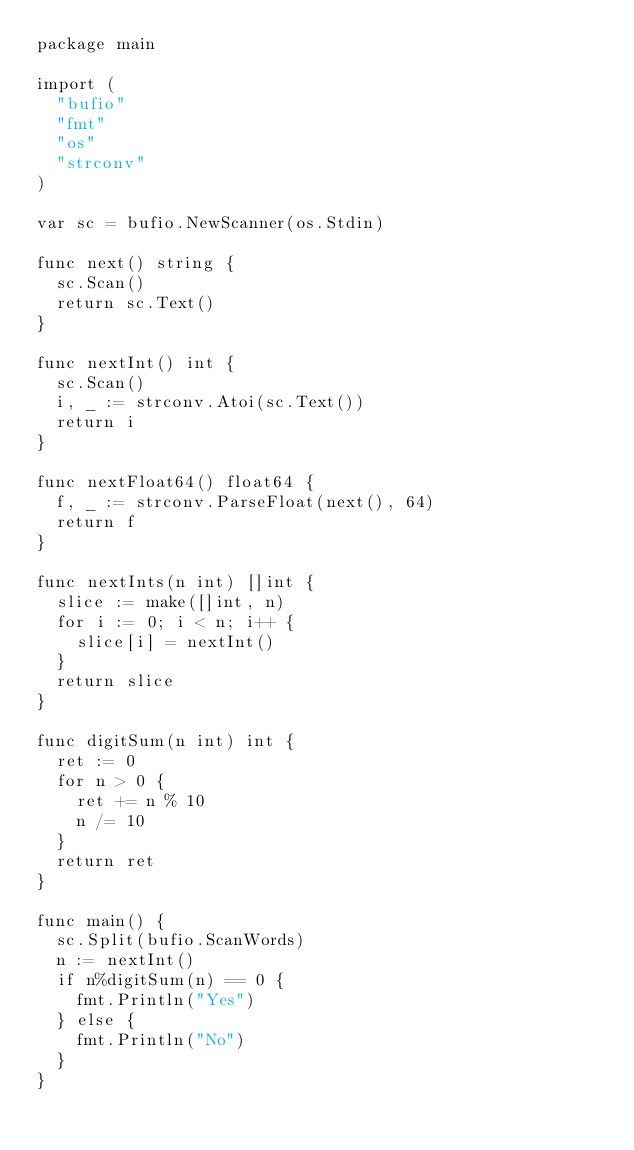<code> <loc_0><loc_0><loc_500><loc_500><_Go_>package main

import (
	"bufio"
	"fmt"
	"os"
	"strconv"
)

var sc = bufio.NewScanner(os.Stdin)

func next() string {
	sc.Scan()
	return sc.Text()
}

func nextInt() int {
	sc.Scan()
	i, _ := strconv.Atoi(sc.Text())
	return i
}

func nextFloat64() float64 {
	f, _ := strconv.ParseFloat(next(), 64)
	return f
}

func nextInts(n int) []int {
	slice := make([]int, n)
	for i := 0; i < n; i++ {
		slice[i] = nextInt()
	}
	return slice
}

func digitSum(n int) int {
	ret := 0
	for n > 0 {
		ret += n % 10
		n /= 10
	}
	return ret
}

func main() {
	sc.Split(bufio.ScanWords)
	n := nextInt()
	if n%digitSum(n) == 0 {
		fmt.Println("Yes")
	} else {
		fmt.Println("No")
	}
}
</code> 